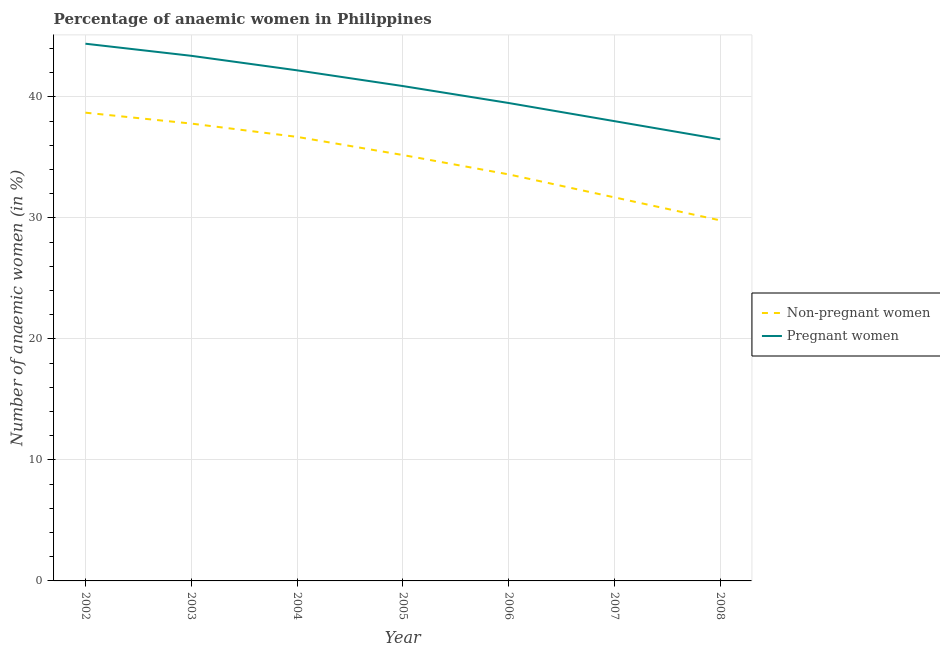Does the line corresponding to percentage of pregnant anaemic women intersect with the line corresponding to percentage of non-pregnant anaemic women?
Make the answer very short. No. Is the number of lines equal to the number of legend labels?
Offer a terse response. Yes. What is the percentage of non-pregnant anaemic women in 2002?
Provide a short and direct response. 38.7. Across all years, what is the maximum percentage of non-pregnant anaemic women?
Give a very brief answer. 38.7. Across all years, what is the minimum percentage of non-pregnant anaemic women?
Your answer should be very brief. 29.8. In which year was the percentage of non-pregnant anaemic women maximum?
Give a very brief answer. 2002. What is the total percentage of non-pregnant anaemic women in the graph?
Provide a succinct answer. 243.5. What is the difference between the percentage of non-pregnant anaemic women in 2002 and that in 2008?
Provide a short and direct response. 8.9. What is the difference between the percentage of non-pregnant anaemic women in 2007 and the percentage of pregnant anaemic women in 2006?
Offer a very short reply. -7.8. What is the average percentage of non-pregnant anaemic women per year?
Your answer should be very brief. 34.79. In the year 2006, what is the difference between the percentage of pregnant anaemic women and percentage of non-pregnant anaemic women?
Ensure brevity in your answer.  5.9. What is the ratio of the percentage of non-pregnant anaemic women in 2003 to that in 2007?
Your response must be concise. 1.19. Is the percentage of non-pregnant anaemic women in 2002 less than that in 2007?
Provide a succinct answer. No. What is the difference between the highest and the second highest percentage of non-pregnant anaemic women?
Give a very brief answer. 0.9. What is the difference between the highest and the lowest percentage of pregnant anaemic women?
Your answer should be compact. 7.9. Is the percentage of non-pregnant anaemic women strictly less than the percentage of pregnant anaemic women over the years?
Ensure brevity in your answer.  Yes. How many years are there in the graph?
Provide a short and direct response. 7. What is the difference between two consecutive major ticks on the Y-axis?
Keep it short and to the point. 10. Are the values on the major ticks of Y-axis written in scientific E-notation?
Ensure brevity in your answer.  No. Does the graph contain any zero values?
Offer a terse response. No. Does the graph contain grids?
Give a very brief answer. Yes. Where does the legend appear in the graph?
Give a very brief answer. Center right. How many legend labels are there?
Provide a short and direct response. 2. What is the title of the graph?
Provide a succinct answer. Percentage of anaemic women in Philippines. Does "Tetanus" appear as one of the legend labels in the graph?
Make the answer very short. No. What is the label or title of the Y-axis?
Your response must be concise. Number of anaemic women (in %). What is the Number of anaemic women (in %) of Non-pregnant women in 2002?
Ensure brevity in your answer.  38.7. What is the Number of anaemic women (in %) in Pregnant women in 2002?
Your answer should be compact. 44.4. What is the Number of anaemic women (in %) of Non-pregnant women in 2003?
Offer a very short reply. 37.8. What is the Number of anaemic women (in %) in Pregnant women in 2003?
Your answer should be very brief. 43.4. What is the Number of anaemic women (in %) of Non-pregnant women in 2004?
Make the answer very short. 36.7. What is the Number of anaemic women (in %) in Pregnant women in 2004?
Provide a short and direct response. 42.2. What is the Number of anaemic women (in %) of Non-pregnant women in 2005?
Your answer should be compact. 35.2. What is the Number of anaemic women (in %) in Pregnant women in 2005?
Your response must be concise. 40.9. What is the Number of anaemic women (in %) of Non-pregnant women in 2006?
Make the answer very short. 33.6. What is the Number of anaemic women (in %) of Pregnant women in 2006?
Provide a succinct answer. 39.5. What is the Number of anaemic women (in %) in Non-pregnant women in 2007?
Your answer should be very brief. 31.7. What is the Number of anaemic women (in %) in Pregnant women in 2007?
Your response must be concise. 38. What is the Number of anaemic women (in %) of Non-pregnant women in 2008?
Offer a very short reply. 29.8. What is the Number of anaemic women (in %) of Pregnant women in 2008?
Offer a very short reply. 36.5. Across all years, what is the maximum Number of anaemic women (in %) of Non-pregnant women?
Provide a succinct answer. 38.7. Across all years, what is the maximum Number of anaemic women (in %) in Pregnant women?
Your answer should be very brief. 44.4. Across all years, what is the minimum Number of anaemic women (in %) in Non-pregnant women?
Give a very brief answer. 29.8. Across all years, what is the minimum Number of anaemic women (in %) in Pregnant women?
Ensure brevity in your answer.  36.5. What is the total Number of anaemic women (in %) in Non-pregnant women in the graph?
Your response must be concise. 243.5. What is the total Number of anaemic women (in %) in Pregnant women in the graph?
Provide a succinct answer. 284.9. What is the difference between the Number of anaemic women (in %) of Pregnant women in 2002 and that in 2003?
Your response must be concise. 1. What is the difference between the Number of anaemic women (in %) of Pregnant women in 2002 and that in 2004?
Your answer should be compact. 2.2. What is the difference between the Number of anaemic women (in %) in Non-pregnant women in 2002 and that in 2005?
Provide a short and direct response. 3.5. What is the difference between the Number of anaemic women (in %) in Pregnant women in 2002 and that in 2005?
Your answer should be very brief. 3.5. What is the difference between the Number of anaemic women (in %) of Non-pregnant women in 2002 and that in 2006?
Your answer should be compact. 5.1. What is the difference between the Number of anaemic women (in %) in Pregnant women in 2002 and that in 2006?
Provide a succinct answer. 4.9. What is the difference between the Number of anaemic women (in %) of Pregnant women in 2002 and that in 2008?
Your answer should be compact. 7.9. What is the difference between the Number of anaemic women (in %) of Non-pregnant women in 2003 and that in 2004?
Offer a very short reply. 1.1. What is the difference between the Number of anaemic women (in %) in Pregnant women in 2003 and that in 2004?
Provide a short and direct response. 1.2. What is the difference between the Number of anaemic women (in %) of Non-pregnant women in 2003 and that in 2005?
Your answer should be very brief. 2.6. What is the difference between the Number of anaemic women (in %) in Pregnant women in 2003 and that in 2005?
Give a very brief answer. 2.5. What is the difference between the Number of anaemic women (in %) in Non-pregnant women in 2003 and that in 2006?
Your answer should be very brief. 4.2. What is the difference between the Number of anaemic women (in %) in Pregnant women in 2003 and that in 2006?
Your answer should be compact. 3.9. What is the difference between the Number of anaemic women (in %) in Non-pregnant women in 2004 and that in 2005?
Provide a succinct answer. 1.5. What is the difference between the Number of anaemic women (in %) of Pregnant women in 2004 and that in 2005?
Provide a succinct answer. 1.3. What is the difference between the Number of anaemic women (in %) of Non-pregnant women in 2004 and that in 2007?
Keep it short and to the point. 5. What is the difference between the Number of anaemic women (in %) in Non-pregnant women in 2004 and that in 2008?
Make the answer very short. 6.9. What is the difference between the Number of anaemic women (in %) of Non-pregnant women in 2005 and that in 2006?
Keep it short and to the point. 1.6. What is the difference between the Number of anaemic women (in %) of Pregnant women in 2005 and that in 2008?
Offer a very short reply. 4.4. What is the difference between the Number of anaemic women (in %) in Non-pregnant women in 2002 and the Number of anaemic women (in %) in Pregnant women in 2005?
Provide a succinct answer. -2.2. What is the difference between the Number of anaemic women (in %) of Non-pregnant women in 2002 and the Number of anaemic women (in %) of Pregnant women in 2008?
Your answer should be very brief. 2.2. What is the difference between the Number of anaemic women (in %) of Non-pregnant women in 2003 and the Number of anaemic women (in %) of Pregnant women in 2004?
Offer a very short reply. -4.4. What is the difference between the Number of anaemic women (in %) of Non-pregnant women in 2003 and the Number of anaemic women (in %) of Pregnant women in 2005?
Provide a short and direct response. -3.1. What is the difference between the Number of anaemic women (in %) in Non-pregnant women in 2003 and the Number of anaemic women (in %) in Pregnant women in 2006?
Give a very brief answer. -1.7. What is the difference between the Number of anaemic women (in %) in Non-pregnant women in 2003 and the Number of anaemic women (in %) in Pregnant women in 2007?
Your answer should be very brief. -0.2. What is the difference between the Number of anaemic women (in %) in Non-pregnant women in 2003 and the Number of anaemic women (in %) in Pregnant women in 2008?
Provide a succinct answer. 1.3. What is the difference between the Number of anaemic women (in %) of Non-pregnant women in 2004 and the Number of anaemic women (in %) of Pregnant women in 2007?
Your answer should be compact. -1.3. What is the difference between the Number of anaemic women (in %) in Non-pregnant women in 2005 and the Number of anaemic women (in %) in Pregnant women in 2006?
Ensure brevity in your answer.  -4.3. What is the difference between the Number of anaemic women (in %) of Non-pregnant women in 2005 and the Number of anaemic women (in %) of Pregnant women in 2007?
Make the answer very short. -2.8. What is the difference between the Number of anaemic women (in %) in Non-pregnant women in 2006 and the Number of anaemic women (in %) in Pregnant women in 2007?
Your answer should be very brief. -4.4. What is the difference between the Number of anaemic women (in %) in Non-pregnant women in 2007 and the Number of anaemic women (in %) in Pregnant women in 2008?
Keep it short and to the point. -4.8. What is the average Number of anaemic women (in %) of Non-pregnant women per year?
Offer a terse response. 34.79. What is the average Number of anaemic women (in %) in Pregnant women per year?
Offer a terse response. 40.7. In the year 2007, what is the difference between the Number of anaemic women (in %) in Non-pregnant women and Number of anaemic women (in %) in Pregnant women?
Provide a short and direct response. -6.3. What is the ratio of the Number of anaemic women (in %) in Non-pregnant women in 2002 to that in 2003?
Offer a terse response. 1.02. What is the ratio of the Number of anaemic women (in %) of Non-pregnant women in 2002 to that in 2004?
Make the answer very short. 1.05. What is the ratio of the Number of anaemic women (in %) in Pregnant women in 2002 to that in 2004?
Offer a very short reply. 1.05. What is the ratio of the Number of anaemic women (in %) in Non-pregnant women in 2002 to that in 2005?
Give a very brief answer. 1.1. What is the ratio of the Number of anaemic women (in %) in Pregnant women in 2002 to that in 2005?
Your response must be concise. 1.09. What is the ratio of the Number of anaemic women (in %) in Non-pregnant women in 2002 to that in 2006?
Give a very brief answer. 1.15. What is the ratio of the Number of anaemic women (in %) of Pregnant women in 2002 to that in 2006?
Your answer should be very brief. 1.12. What is the ratio of the Number of anaemic women (in %) of Non-pregnant women in 2002 to that in 2007?
Your response must be concise. 1.22. What is the ratio of the Number of anaemic women (in %) in Pregnant women in 2002 to that in 2007?
Give a very brief answer. 1.17. What is the ratio of the Number of anaemic women (in %) in Non-pregnant women in 2002 to that in 2008?
Your answer should be very brief. 1.3. What is the ratio of the Number of anaemic women (in %) in Pregnant women in 2002 to that in 2008?
Your answer should be compact. 1.22. What is the ratio of the Number of anaemic women (in %) in Non-pregnant women in 2003 to that in 2004?
Keep it short and to the point. 1.03. What is the ratio of the Number of anaemic women (in %) in Pregnant women in 2003 to that in 2004?
Your response must be concise. 1.03. What is the ratio of the Number of anaemic women (in %) of Non-pregnant women in 2003 to that in 2005?
Make the answer very short. 1.07. What is the ratio of the Number of anaemic women (in %) of Pregnant women in 2003 to that in 2005?
Keep it short and to the point. 1.06. What is the ratio of the Number of anaemic women (in %) in Non-pregnant women in 2003 to that in 2006?
Ensure brevity in your answer.  1.12. What is the ratio of the Number of anaemic women (in %) of Pregnant women in 2003 to that in 2006?
Your answer should be compact. 1.1. What is the ratio of the Number of anaemic women (in %) in Non-pregnant women in 2003 to that in 2007?
Keep it short and to the point. 1.19. What is the ratio of the Number of anaemic women (in %) in Pregnant women in 2003 to that in 2007?
Keep it short and to the point. 1.14. What is the ratio of the Number of anaemic women (in %) in Non-pregnant women in 2003 to that in 2008?
Give a very brief answer. 1.27. What is the ratio of the Number of anaemic women (in %) of Pregnant women in 2003 to that in 2008?
Make the answer very short. 1.19. What is the ratio of the Number of anaemic women (in %) in Non-pregnant women in 2004 to that in 2005?
Your answer should be compact. 1.04. What is the ratio of the Number of anaemic women (in %) of Pregnant women in 2004 to that in 2005?
Give a very brief answer. 1.03. What is the ratio of the Number of anaemic women (in %) in Non-pregnant women in 2004 to that in 2006?
Your response must be concise. 1.09. What is the ratio of the Number of anaemic women (in %) of Pregnant women in 2004 to that in 2006?
Your answer should be compact. 1.07. What is the ratio of the Number of anaemic women (in %) of Non-pregnant women in 2004 to that in 2007?
Make the answer very short. 1.16. What is the ratio of the Number of anaemic women (in %) of Pregnant women in 2004 to that in 2007?
Ensure brevity in your answer.  1.11. What is the ratio of the Number of anaemic women (in %) in Non-pregnant women in 2004 to that in 2008?
Ensure brevity in your answer.  1.23. What is the ratio of the Number of anaemic women (in %) of Pregnant women in 2004 to that in 2008?
Provide a short and direct response. 1.16. What is the ratio of the Number of anaemic women (in %) of Non-pregnant women in 2005 to that in 2006?
Your response must be concise. 1.05. What is the ratio of the Number of anaemic women (in %) of Pregnant women in 2005 to that in 2006?
Offer a terse response. 1.04. What is the ratio of the Number of anaemic women (in %) of Non-pregnant women in 2005 to that in 2007?
Offer a terse response. 1.11. What is the ratio of the Number of anaemic women (in %) of Pregnant women in 2005 to that in 2007?
Provide a short and direct response. 1.08. What is the ratio of the Number of anaemic women (in %) in Non-pregnant women in 2005 to that in 2008?
Give a very brief answer. 1.18. What is the ratio of the Number of anaemic women (in %) of Pregnant women in 2005 to that in 2008?
Offer a very short reply. 1.12. What is the ratio of the Number of anaemic women (in %) in Non-pregnant women in 2006 to that in 2007?
Offer a terse response. 1.06. What is the ratio of the Number of anaemic women (in %) of Pregnant women in 2006 to that in 2007?
Keep it short and to the point. 1.04. What is the ratio of the Number of anaemic women (in %) of Non-pregnant women in 2006 to that in 2008?
Offer a terse response. 1.13. What is the ratio of the Number of anaemic women (in %) in Pregnant women in 2006 to that in 2008?
Your answer should be very brief. 1.08. What is the ratio of the Number of anaemic women (in %) of Non-pregnant women in 2007 to that in 2008?
Provide a succinct answer. 1.06. What is the ratio of the Number of anaemic women (in %) in Pregnant women in 2007 to that in 2008?
Provide a short and direct response. 1.04. What is the difference between the highest and the second highest Number of anaemic women (in %) in Pregnant women?
Offer a terse response. 1. 